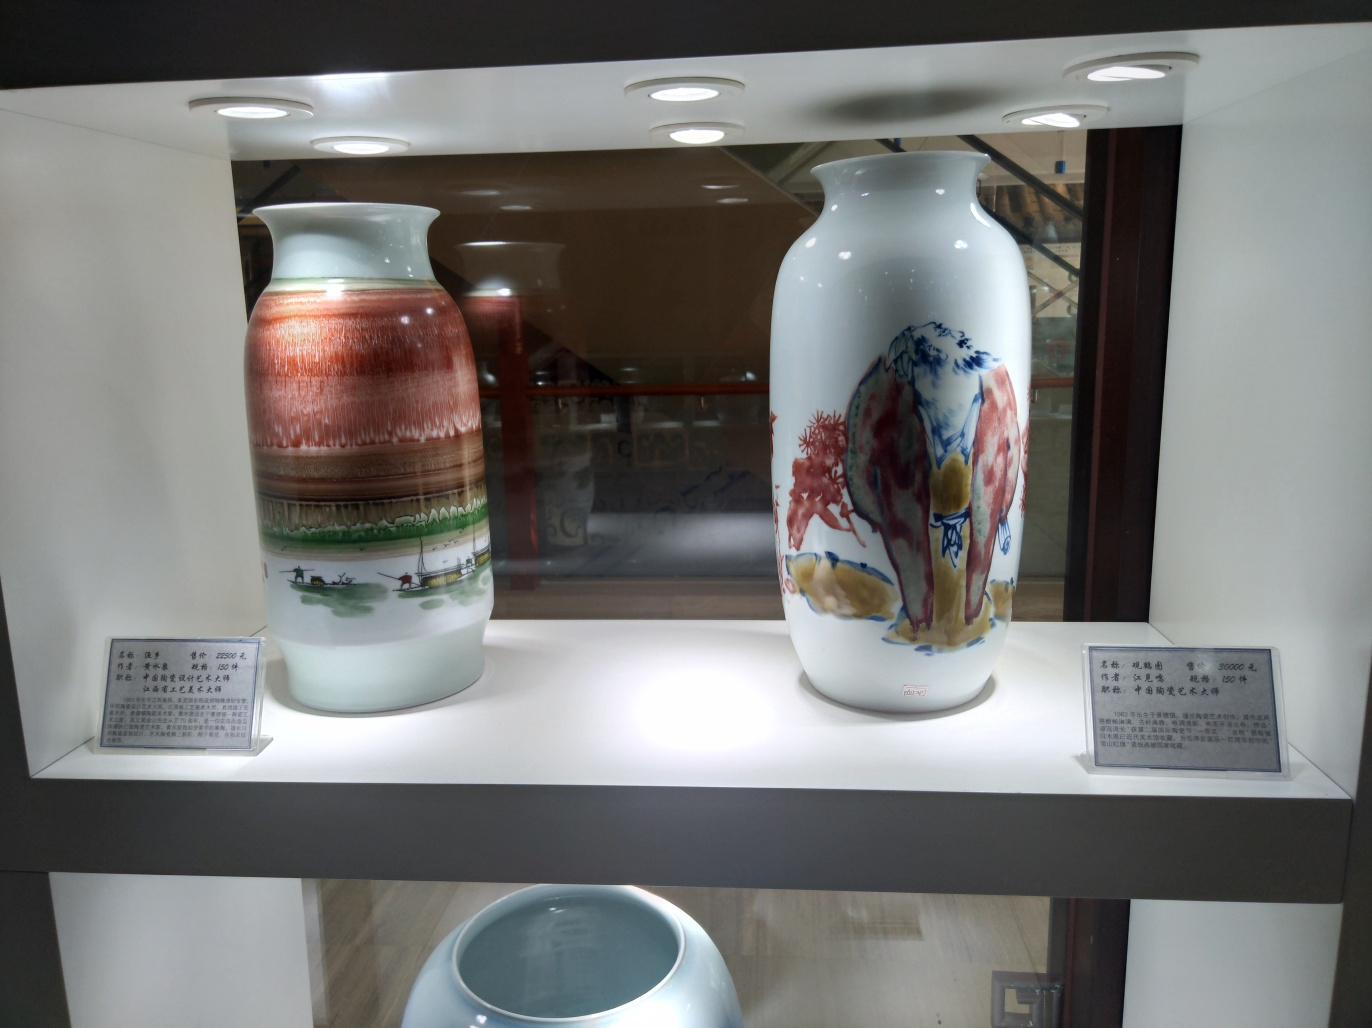Can you tell me more about the style or time period of the vases pictured in the image? Certainly! The left vase features a landscape design that is reminiscent of traditional Chinese porcelain art, suggesting it may belong to a classic or historical collection. The detailed scenes often depict elements of nature and daily life, pointing to a deep appreciation for harmony and narrative in art. On the right, the vase appears to display more abstract floral designs, and the style seems more modern, possibly denoting a contemporary interpretation of porcelain artwork by integrating traditional motifs with a modern aesthetic. Without details from the placards, it's difficult to specify the exact time period. 